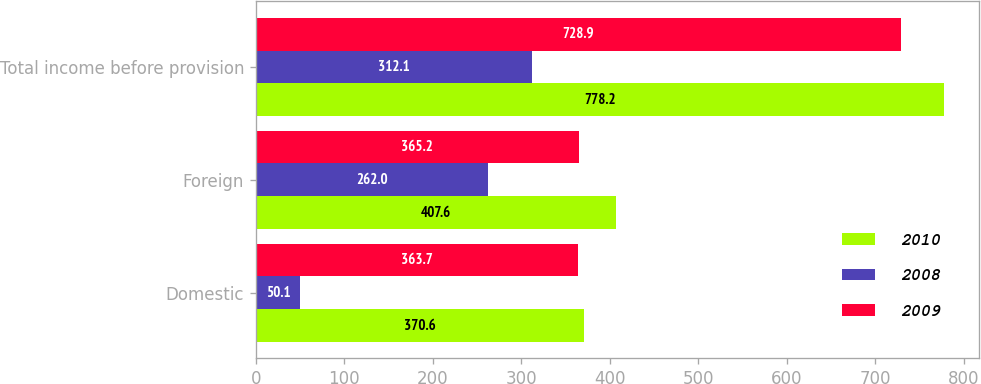<chart> <loc_0><loc_0><loc_500><loc_500><stacked_bar_chart><ecel><fcel>Domestic<fcel>Foreign<fcel>Total income before provision<nl><fcel>2010<fcel>370.6<fcel>407.6<fcel>778.2<nl><fcel>2008<fcel>50.1<fcel>262<fcel>312.1<nl><fcel>2009<fcel>363.7<fcel>365.2<fcel>728.9<nl></chart> 